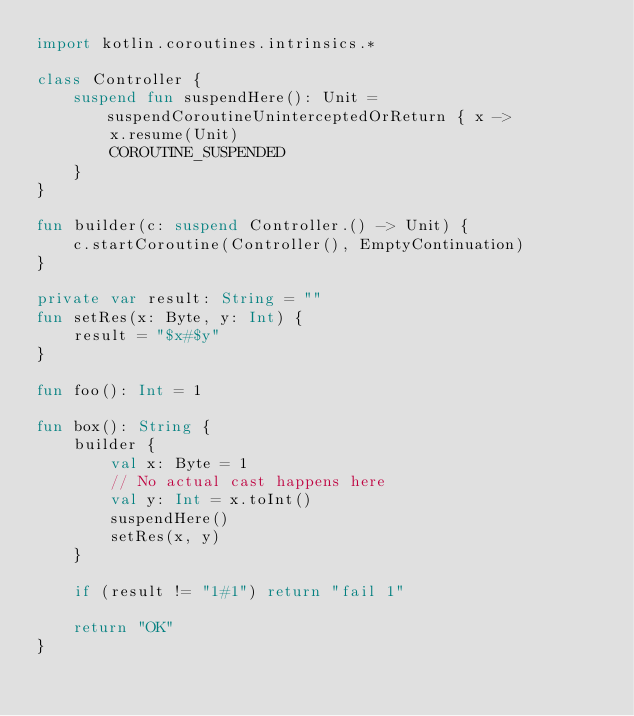<code> <loc_0><loc_0><loc_500><loc_500><_Kotlin_>import kotlin.coroutines.intrinsics.*

class Controller {
    suspend fun suspendHere(): Unit = suspendCoroutineUninterceptedOrReturn { x ->
        x.resume(Unit)
        COROUTINE_SUSPENDED
    }
}

fun builder(c: suspend Controller.() -> Unit) {
    c.startCoroutine(Controller(), EmptyContinuation)
}

private var result: String = ""
fun setRes(x: Byte, y: Int) {
    result = "$x#$y"
}

fun foo(): Int = 1

fun box(): String {
    builder {
        val x: Byte = 1
        // No actual cast happens here
        val y: Int = x.toInt()
        suspendHere()
        setRes(x, y)
    }

    if (result != "1#1") return "fail 1"

    return "OK"
}
</code> 